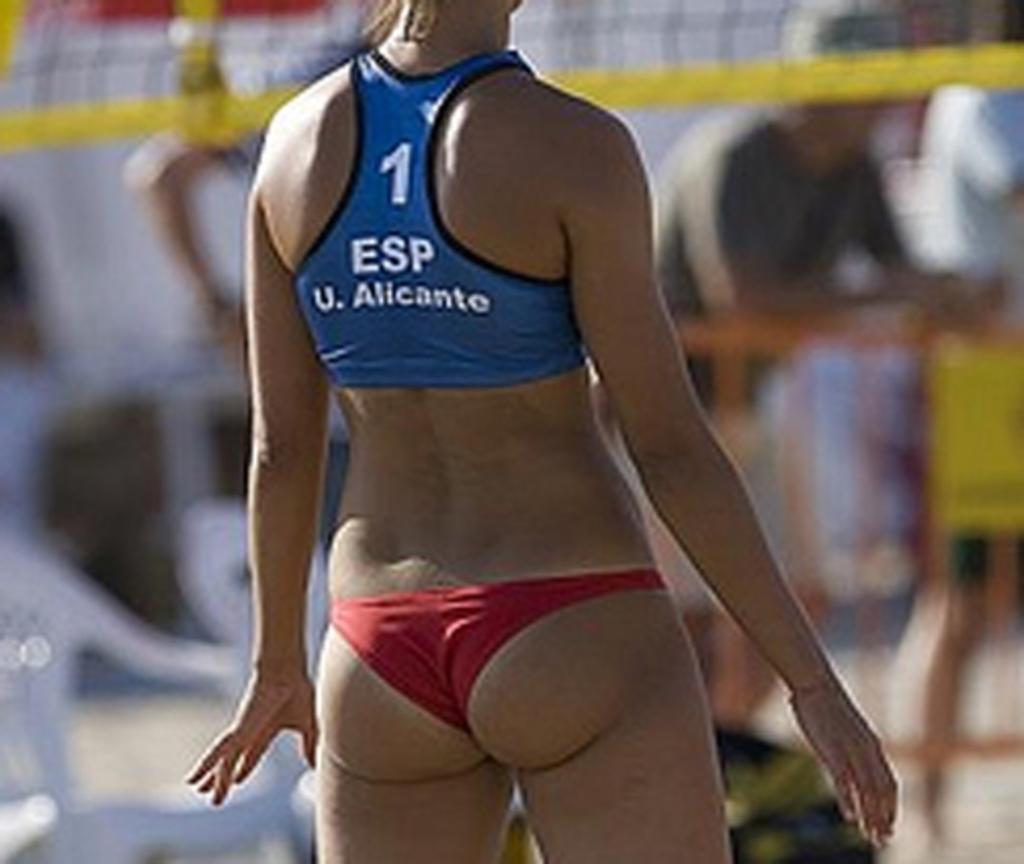Describe this image in one or two sentences. In this image I can see a woman is standing. In the background I can see people and chairs. The background of the image is blurred. 